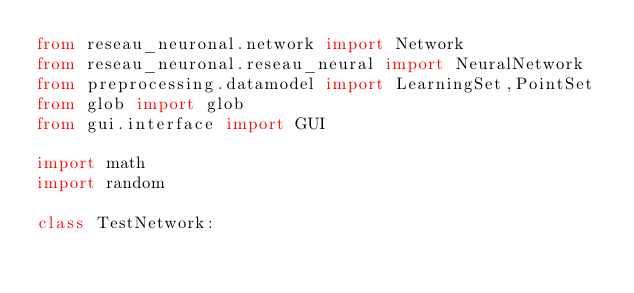Convert code to text. <code><loc_0><loc_0><loc_500><loc_500><_Python_>from reseau_neuronal.network import Network
from reseau_neuronal.reseau_neural import NeuralNetwork
from preprocessing.datamodel import LearningSet,PointSet
from glob import glob
from gui.interface import GUI

import math
import random

class TestNetwork:</code> 